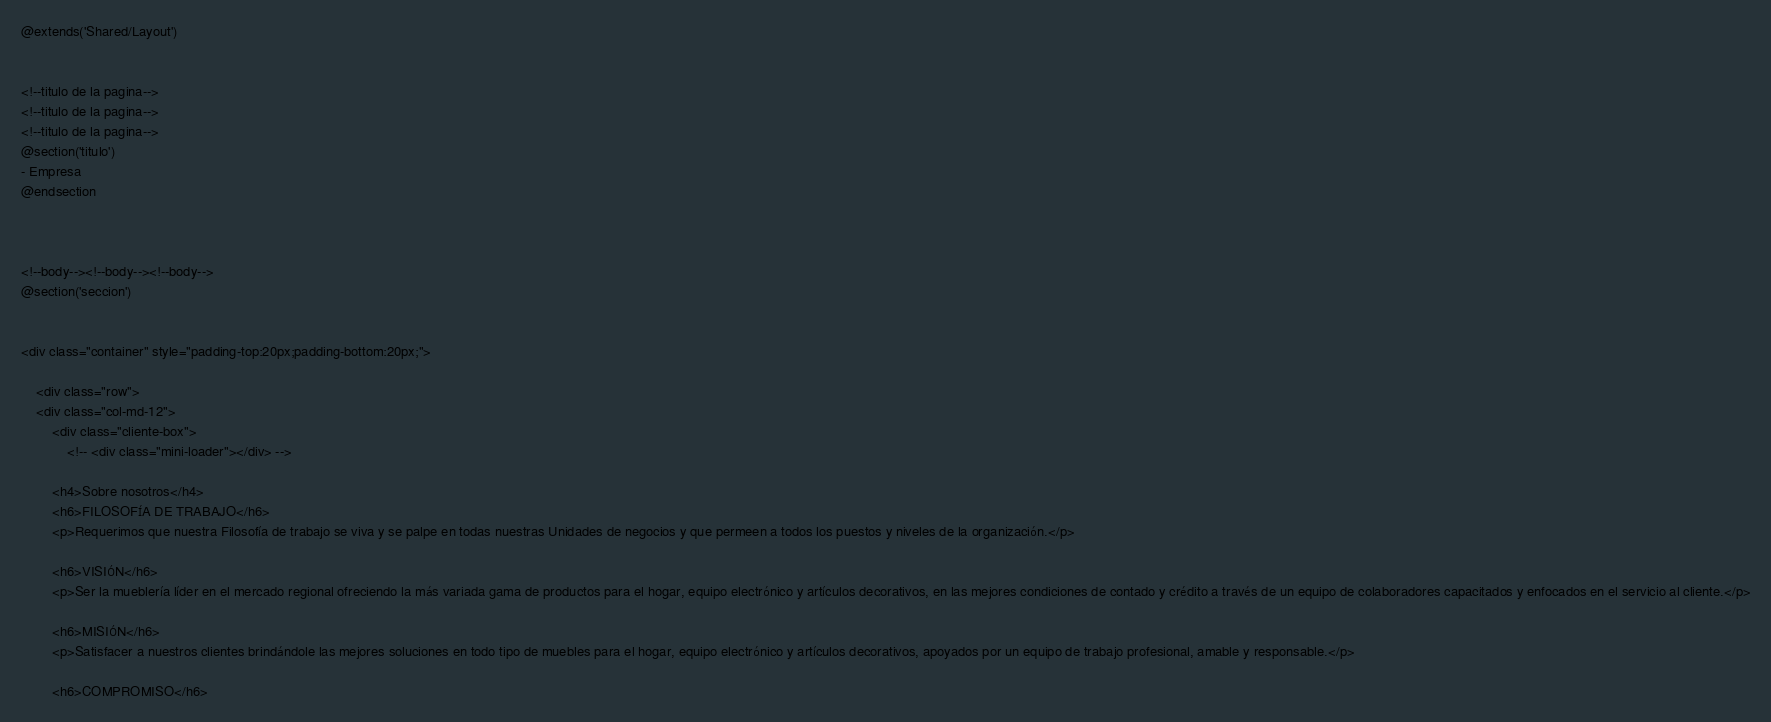Convert code to text. <code><loc_0><loc_0><loc_500><loc_500><_PHP_>@extends('Shared/Layout')


<!--titulo de la pagina-->
<!--titulo de la pagina-->
<!--titulo de la pagina-->
@section('titulo')
- Empresa
@endsection



<!--body--><!--body--><!--body-->
@section('seccion')


<div class="container" style="padding-top:20px;padding-bottom:20px;">

	<div class="row">
	<div class="col-md-12">
		<div class="cliente-box">
			<!-- <div class="mini-loader"></div> -->

		<h4>Sobre nosotros</h4>
		<h6>FILOSOFÍA DE TRABAJO</h6>
		<p>Requerimos que nuestra Filosofía de trabajo se viva y se palpe en todas nuestras Unidades de negocios y que permeen a todos los puestos y niveles de la organización.</p>

		<h6>VISIÓN</h6>
		<p>Ser la mueblería líder en el mercado regional ofreciendo la más variada gama de productos para el hogar, equipo electrónico y artículos decorativos, en las mejores condiciones de contado y crédito a través de un equipo de colaboradores capacitados y enfocados en el servicio al cliente.</p>

		<h6>MISIÓN</h6>
		<p>Satisfacer a nuestros clientes brindándole las mejores soluciones en todo tipo de muebles para el hogar, equipo electrónico y artículos decorativos, apoyados por un equipo de trabajo profesional, amable y responsable.</p>

		<h6>COMPROMISO</h6></code> 